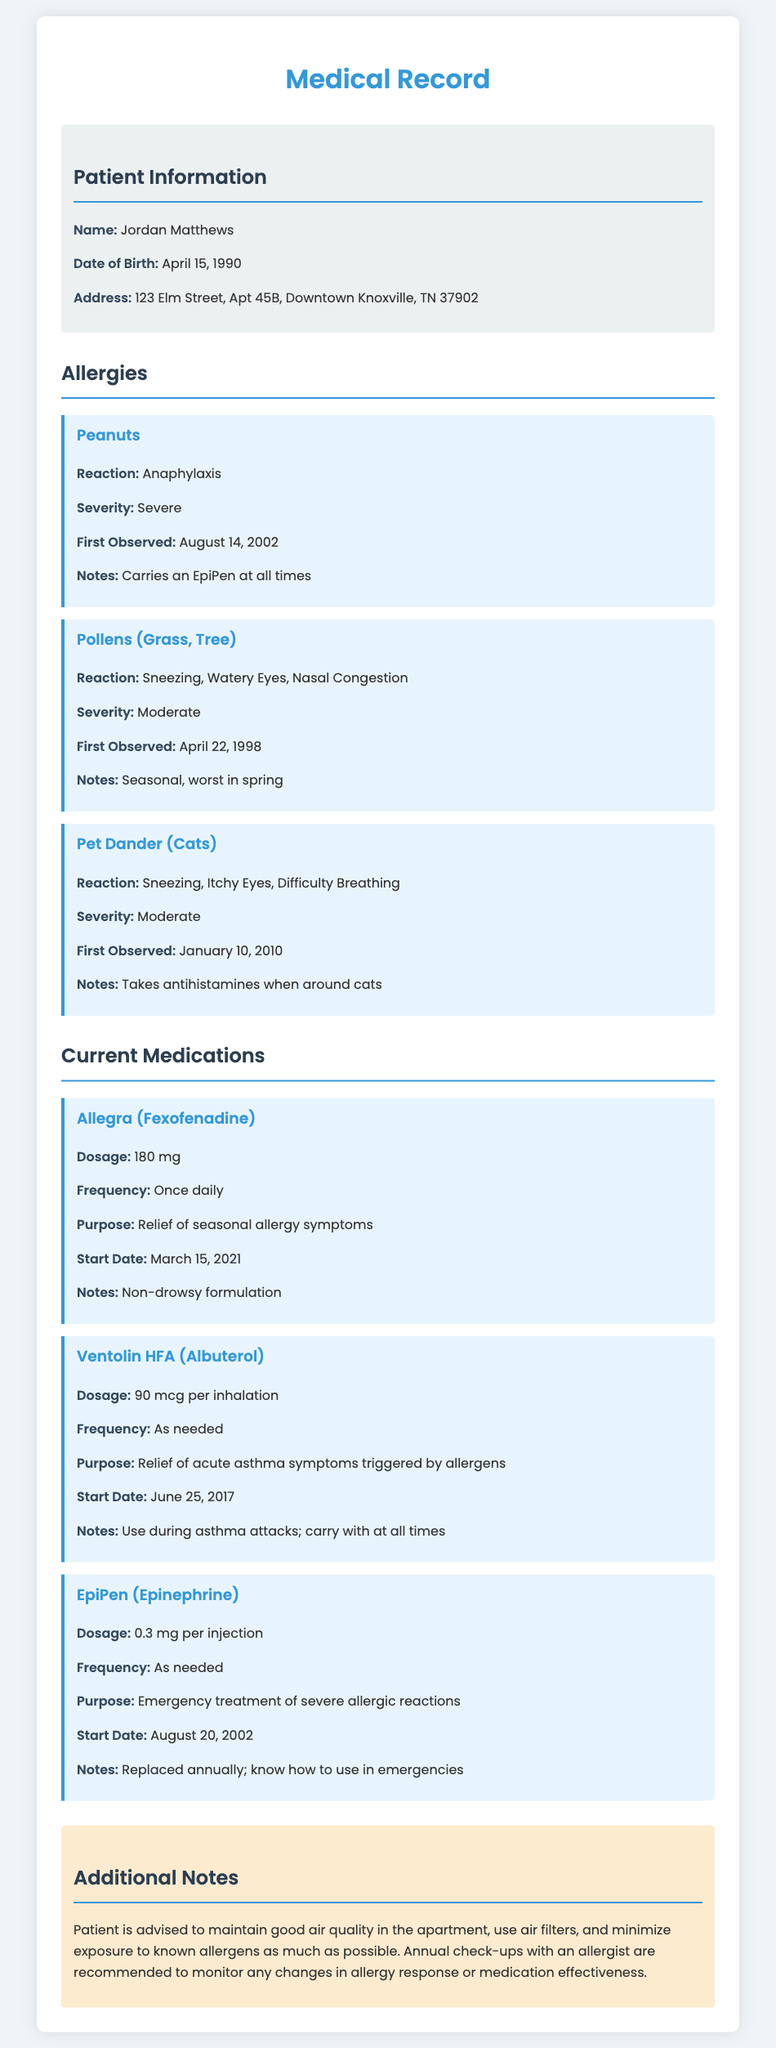What is the patient's name? The document provides the name of the patient at the top of the patient information section.
Answer: Jordan Matthews What is the reaction to peanut allergies? The document specifies the type of reaction experienced by the patient when exposed to peanuts in the allergies section.
Answer: Anaphylaxis What medication is taken for seasonal allergies? The document lists Allegra as the medication prescribed for allergy symptoms in the current medications section.
Answer: Allegra (Fexofenadine) When was the pet dander allergy first observed? The date the pet dander allergy was first documented is included in the allergies section.
Answer: January 10, 2010 How often is Ventolin HFA used? The frequency of use for Ventolin HFA is specified in the medications section.
Answer: As needed What should the patient do during asthma attacks? The instructions regarding the use of Ventolin HFA during asthma attacks are found in the medications section.
Answer: Use during asthma attacks What is the dosage for the EpiPen? The document includes the dosage amount for the EpiPen in the current medications section.
Answer: 0.3 mg per injection What is recommended for maintaining air quality in the apartment? The document advises the patient on maintaining air quality in the additional notes section.
Answer: Use air filters How long has the patient been taking Allegra? The start date for Allegra, indicating how long the patient has been taking it, is documented in the medications section.
Answer: Since March 15, 2021 